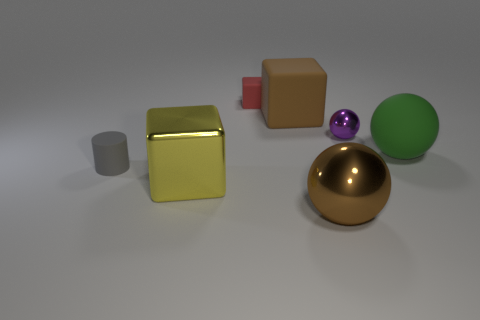Subtract all metal spheres. How many spheres are left? 1 Subtract all cylinders. How many objects are left? 6 Add 1 large blocks. How many objects exist? 8 Subtract all cyan spheres. How many yellow cubes are left? 1 Subtract all big purple objects. Subtract all metallic balls. How many objects are left? 5 Add 6 gray rubber cylinders. How many gray rubber cylinders are left? 7 Add 5 blue balls. How many blue balls exist? 5 Subtract all green spheres. How many spheres are left? 2 Subtract 0 yellow balls. How many objects are left? 7 Subtract 2 cubes. How many cubes are left? 1 